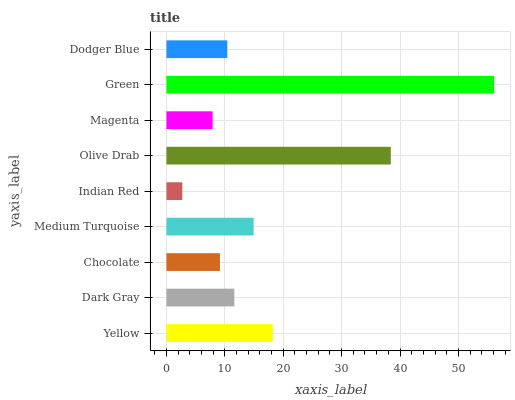Is Indian Red the minimum?
Answer yes or no. Yes. Is Green the maximum?
Answer yes or no. Yes. Is Dark Gray the minimum?
Answer yes or no. No. Is Dark Gray the maximum?
Answer yes or no. No. Is Yellow greater than Dark Gray?
Answer yes or no. Yes. Is Dark Gray less than Yellow?
Answer yes or no. Yes. Is Dark Gray greater than Yellow?
Answer yes or no. No. Is Yellow less than Dark Gray?
Answer yes or no. No. Is Dark Gray the high median?
Answer yes or no. Yes. Is Dark Gray the low median?
Answer yes or no. Yes. Is Magenta the high median?
Answer yes or no. No. Is Dodger Blue the low median?
Answer yes or no. No. 